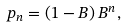Convert formula to latex. <formula><loc_0><loc_0><loc_500><loc_500>p _ { n } = ( 1 - B ) \, B ^ { n } ,</formula> 